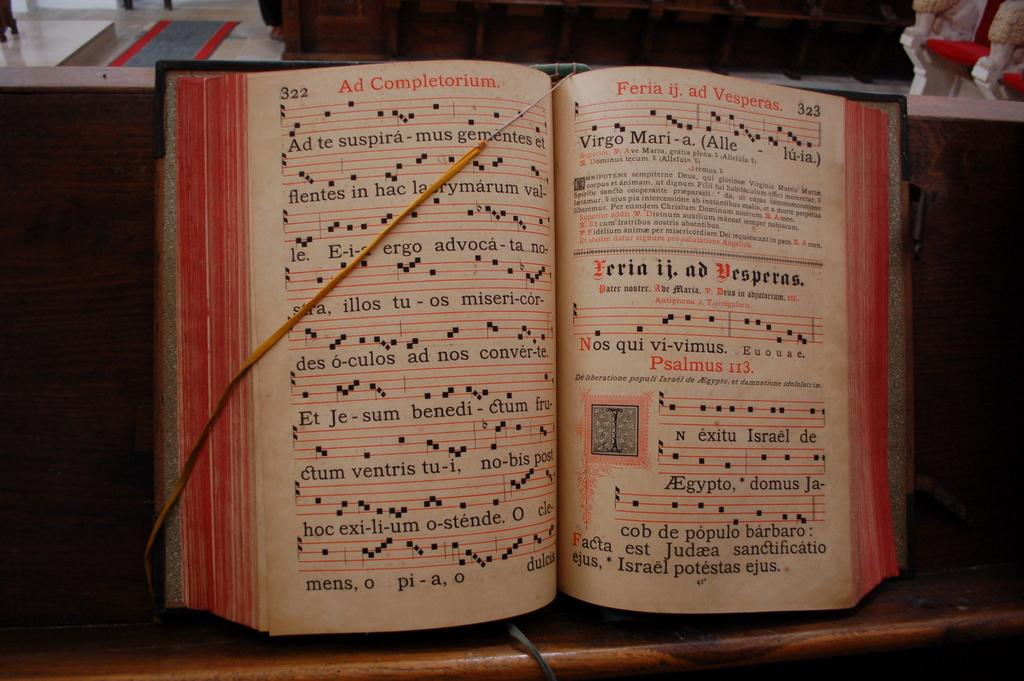<image>
Give a short and clear explanation of the subsequent image. A book of sheet music is held open by a strong, the left side titled Ad Completorium. 